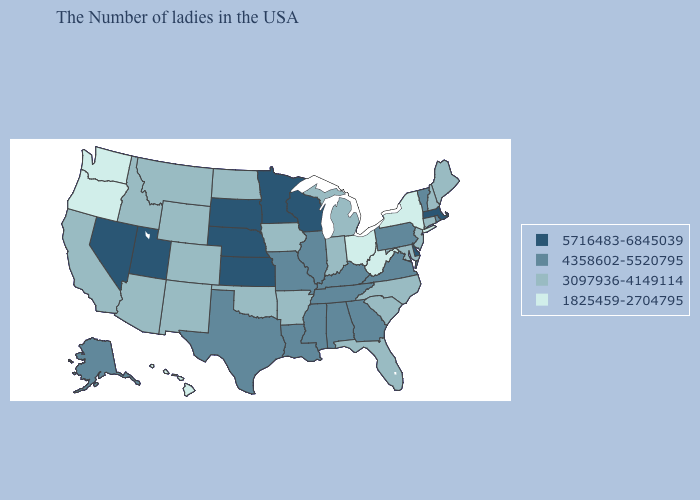Does Georgia have the highest value in the South?
Keep it brief. No. How many symbols are there in the legend?
Answer briefly. 4. Does Kansas have the highest value in the USA?
Quick response, please. Yes. What is the value of Minnesota?
Keep it brief. 5716483-6845039. Does the first symbol in the legend represent the smallest category?
Give a very brief answer. No. What is the lowest value in states that border Nevada?
Quick response, please. 1825459-2704795. Does Delaware have the highest value in the USA?
Write a very short answer. Yes. What is the value of Montana?
Keep it brief. 3097936-4149114. What is the value of Maryland?
Answer briefly. 3097936-4149114. What is the highest value in the USA?
Short answer required. 5716483-6845039. Among the states that border Missouri , does Illinois have the highest value?
Write a very short answer. No. Does Tennessee have a lower value than New Jersey?
Concise answer only. No. Does Alaska have the highest value in the West?
Keep it brief. No. Name the states that have a value in the range 5716483-6845039?
Be succinct. Massachusetts, Delaware, Wisconsin, Minnesota, Kansas, Nebraska, South Dakota, Utah, Nevada. Does the map have missing data?
Concise answer only. No. 